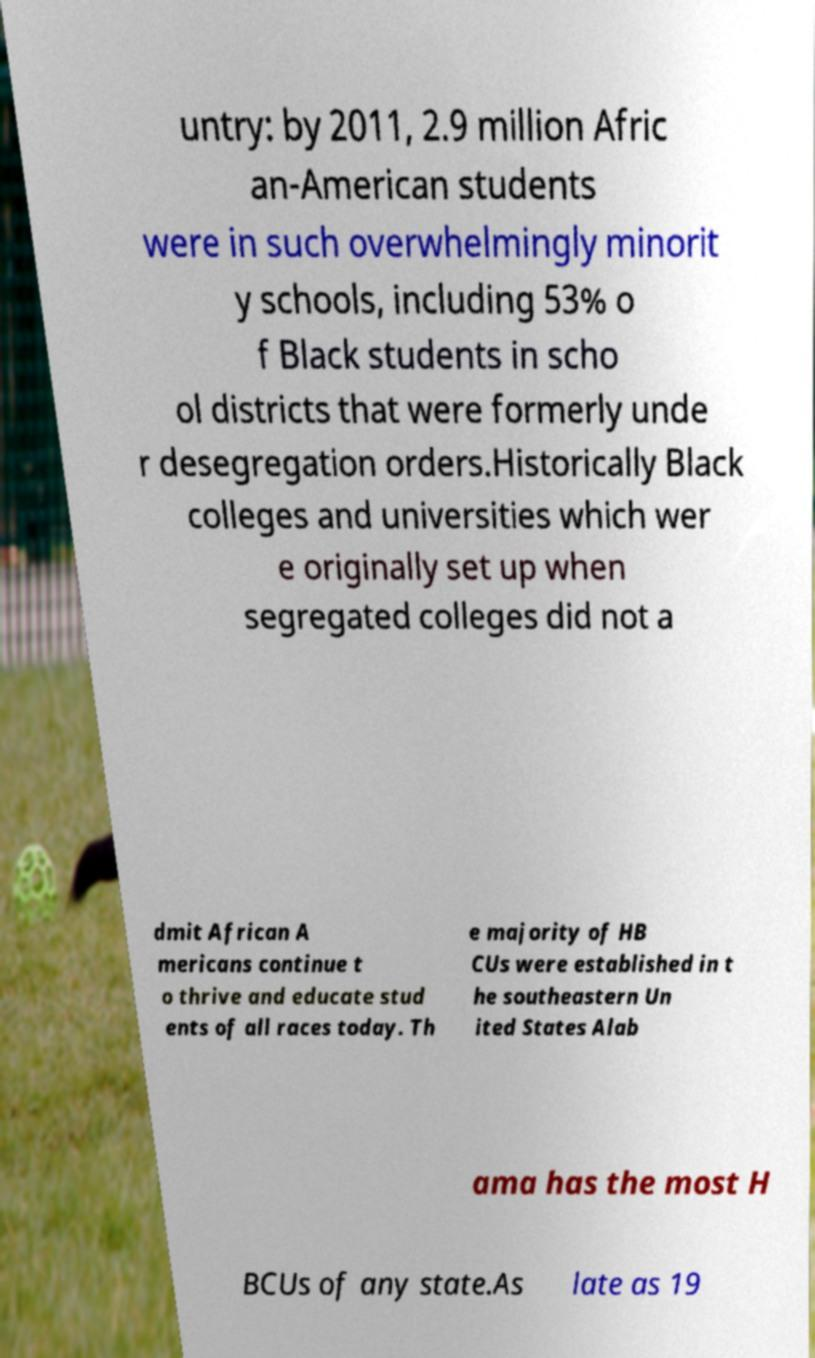Please read and relay the text visible in this image. What does it say? untry: by 2011, 2.9 million Afric an-American students were in such overwhelmingly minorit y schools, including 53% o f Black students in scho ol districts that were formerly unde r desegregation orders.Historically Black colleges and universities which wer e originally set up when segregated colleges did not a dmit African A mericans continue t o thrive and educate stud ents of all races today. Th e majority of HB CUs were established in t he southeastern Un ited States Alab ama has the most H BCUs of any state.As late as 19 